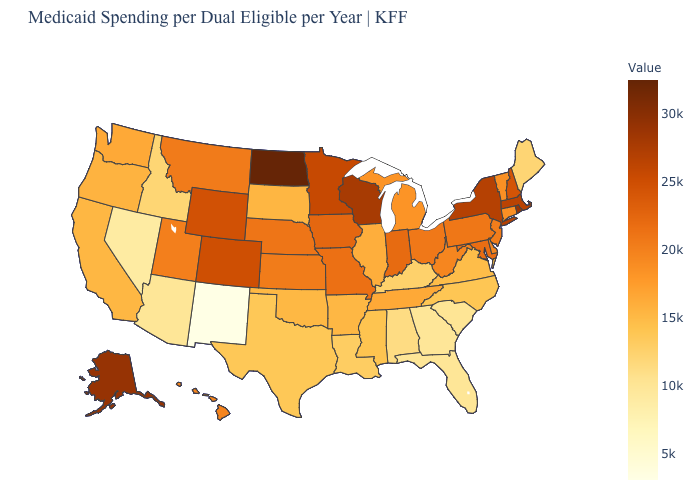Among the states that border Georgia , which have the highest value?
Keep it brief. Tennessee. Does the map have missing data?
Quick response, please. No. Which states have the lowest value in the West?
Be succinct. New Mexico. Does Washington have the lowest value in the West?
Be succinct. No. Does Kentucky have a higher value than New Mexico?
Quick response, please. Yes. 